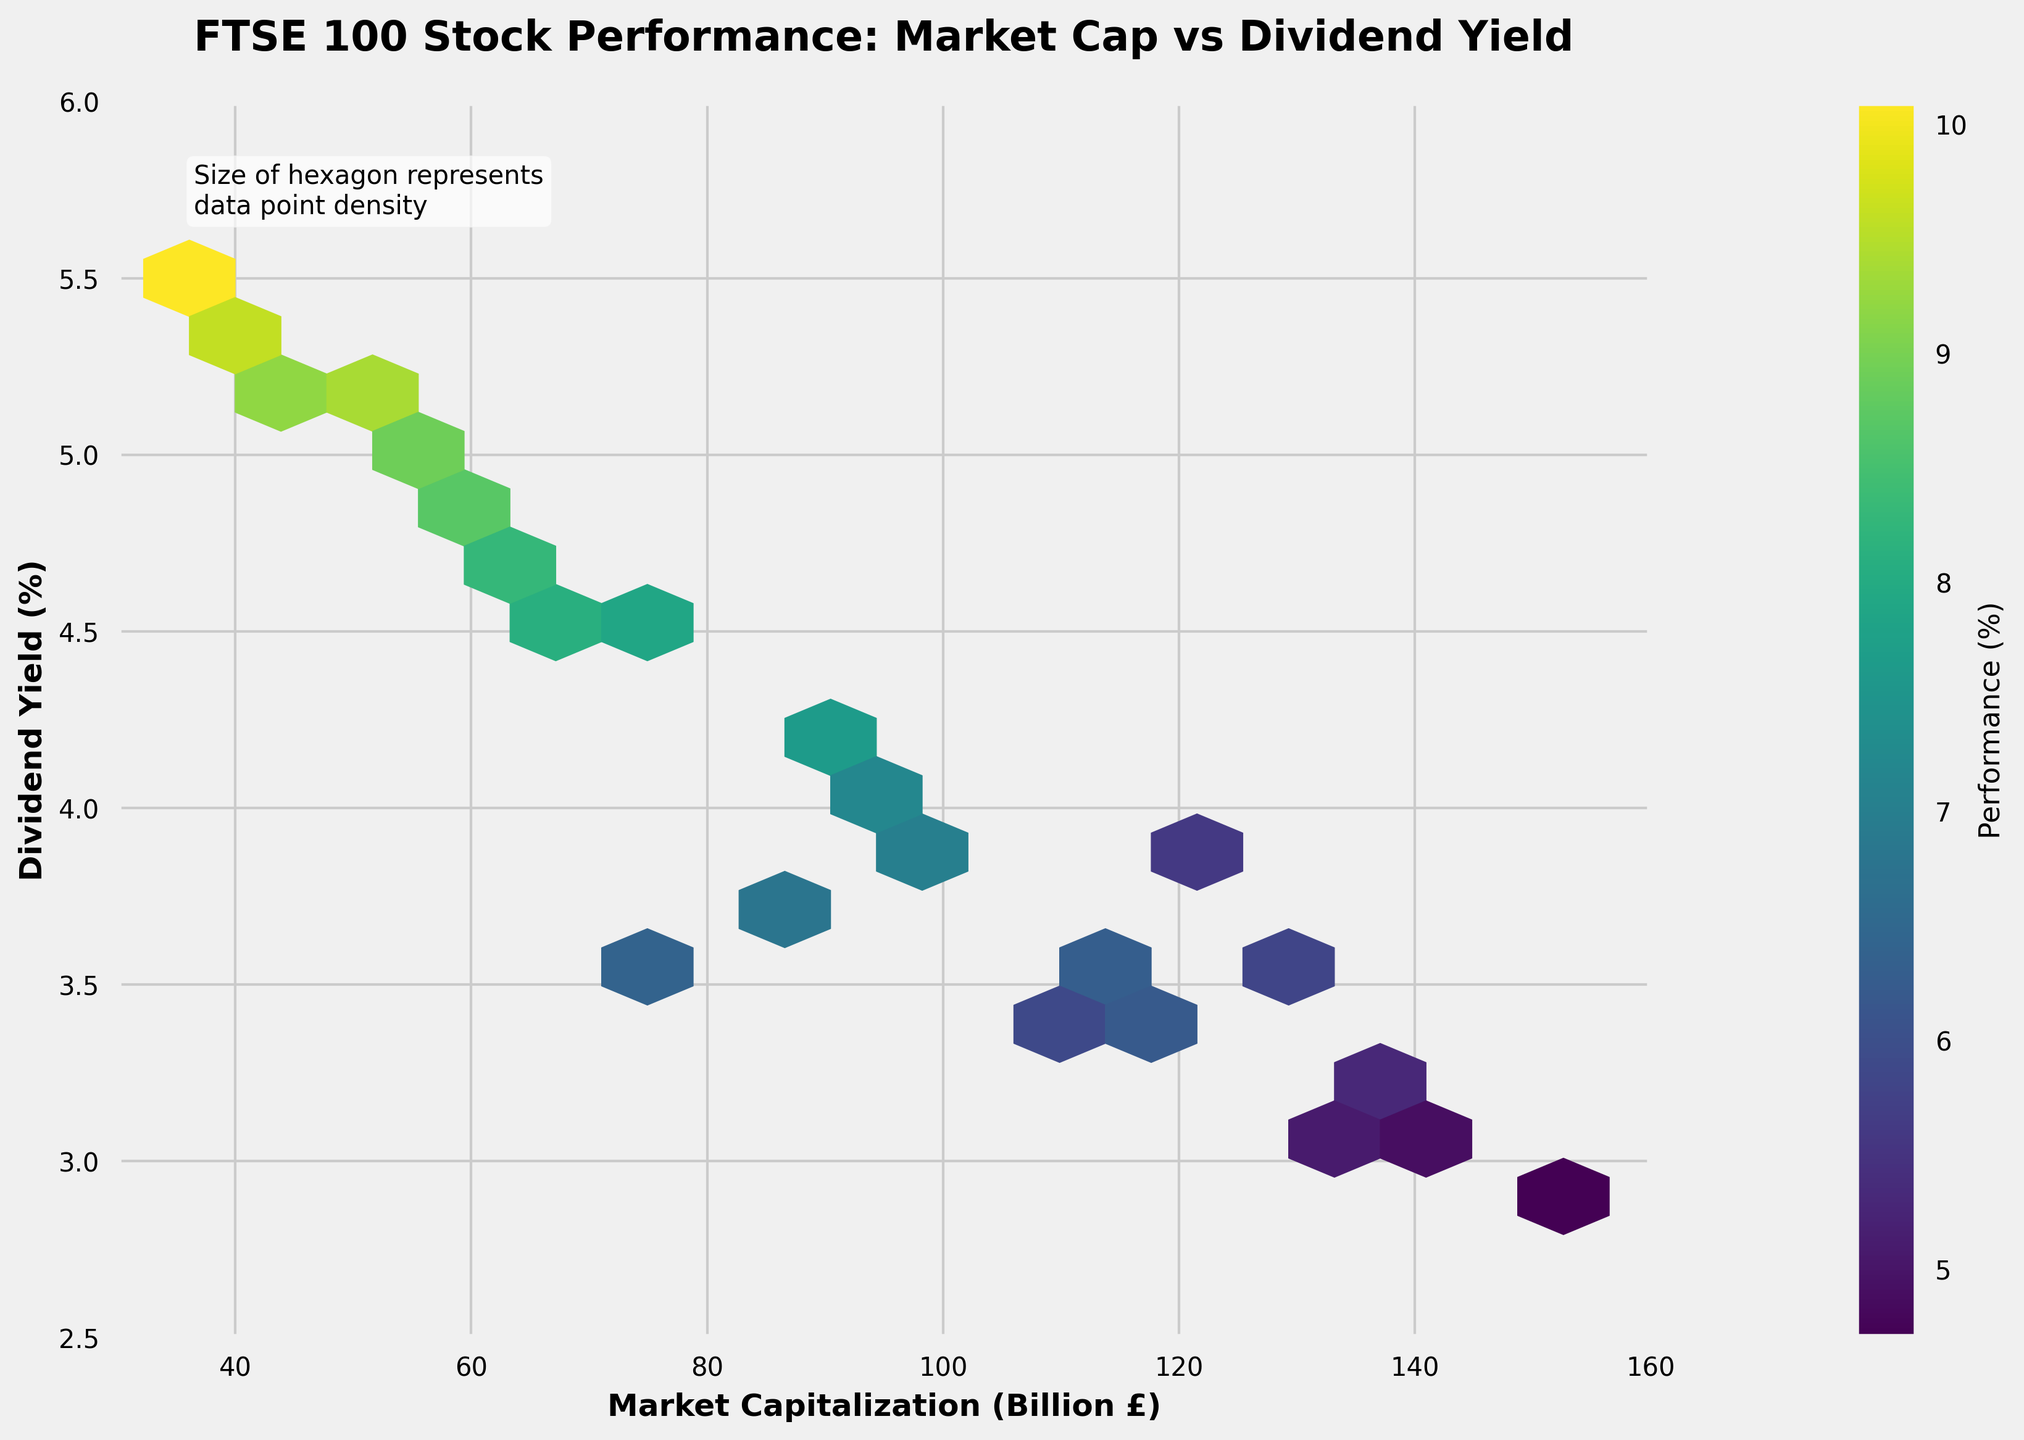What is the title of the plot? The title is usually placed at the top of the plot and is easily noticeable due to its font size and formatting. In this case, the title is "FTSE 100 Stock Performance: Market Cap vs Dividend Yield".
Answer: FTSE 100 Stock Performance: Market Cap vs Dividend Yield What do the x-axis and y-axis represent? The labels on the x-axis and y-axis indicate what each axis represents. Here, the x-axis represents "Market Capitalization (Billion £)" and the y-axis represents "Dividend Yield (%)".
Answer: Market Capitalization (Billion £) and Dividend Yield (%) What does the color of the hexagons represent in the plot? The color of the hexagons is explained by the color bar to the right of the plot. The label on the color bar indicates that the color represents "Performance (%)".
Answer: Performance (%) How many data points contribute to the hexagon with the highest density? The note at the top left corner of the plot indicates that the size of the hexagon represents data point density. To find the hexagon with the highest density, locate the largest hexagon on the plot and infer its count from the legend's lower threshold "mincnt=1".
Answer: Varies per the plot but generally the largest hexagon's size What is the trend between Market Capitalization and Dividend Yield? Observing the spread and concentration of hexagons can reveal the trend. Higher densities indicate more data points. From the plot, you can infer if there's any visible trend, for example, a cluster of high market cap associated mostly with lower or mid-range dividend yields.
Answer: Varied, no clear single trend Which range of Market Capitalization has the highest performance? To determine this, one should identify the range of the x-axis that corresponds to the hexagons with the highest color intensity (representing the highest performance %.
Answer: Roughly around 40-60 Billion £ Are there any data points with both low Market Cap and high Dividend Yield? To answer, observe the left side of the plot along the x-axis (low Market Cap) and look for any hexagons towards the upper part of the plot (high Dividend Yield).
Answer: Yes What's the general relationship between Market Cap and Performance as depicted in the hexbin plot? Analyzing larger areas with higher levels of color intensity (Performance), you can infer if there are any patterns, for instance, whether lower or higher Market Caps generally have better performance.
Answer: Generally mixed; no clear trend What is the average Performance for stocks with a Market Cap over 100 Billion £? Identify the hexagons on the right side of the plot (over 100 Billion £) and note their color (performance %) to compute an average value. Generally, darker colors indicate lower performance and lighter colors higher.
Answer: Around 5-6% Is there a visible correlation between Dividend Yield and Performance in the figure? To find this, observe if the hexagons are showing a pattern where changes in Dividend Yield consistently result in changes in Performance. Look for linearity or clustering patterns.
Answer: Not a strong visible correlation 